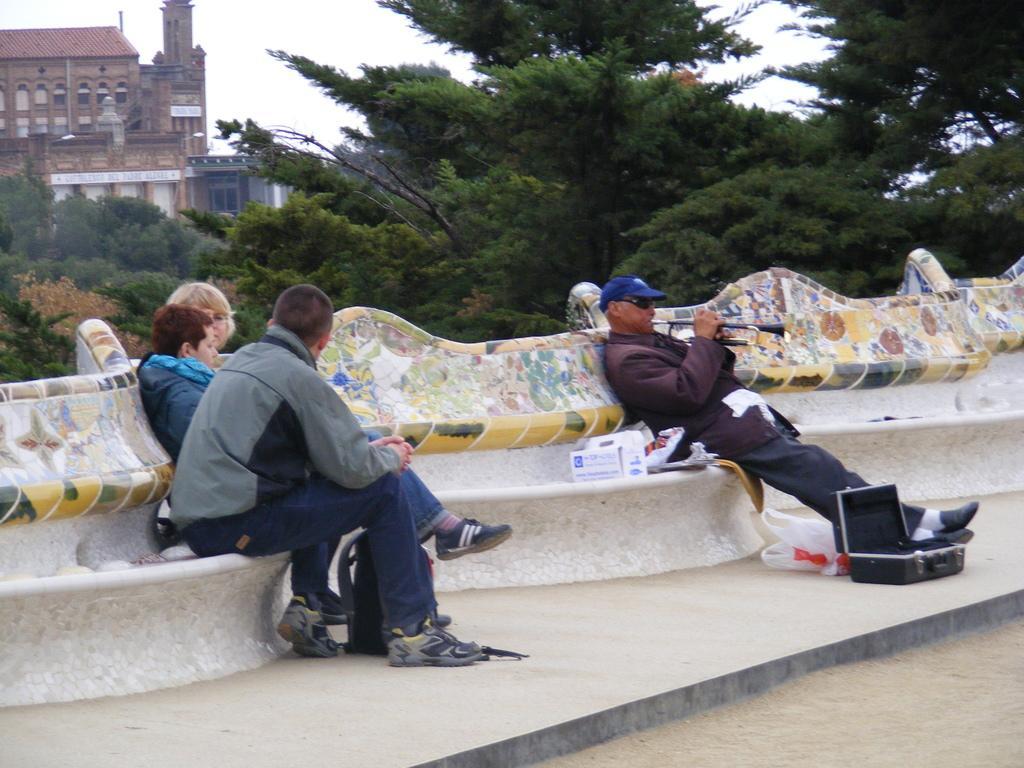In one or two sentences, can you explain what this image depicts? Here is the man sitting and playing the musical instrument. I can see a cardboard box and a cover are placed on the bench. There are three people sitting on the bench. This looks like a suitcase, which is placed on the ground. These are the trees. I can see a building with windows. 